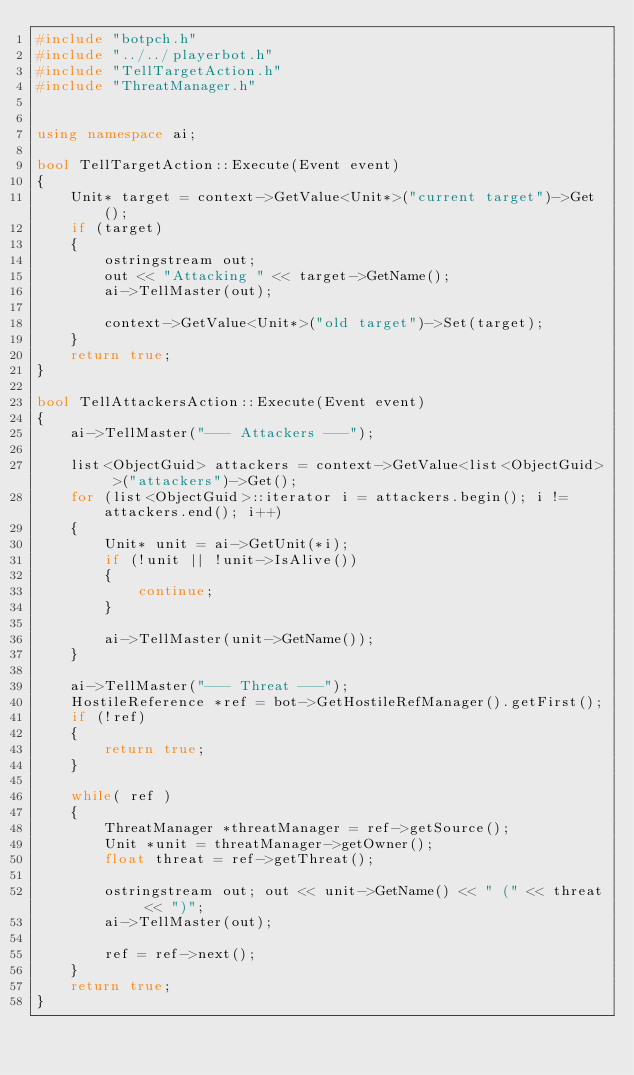Convert code to text. <code><loc_0><loc_0><loc_500><loc_500><_C++_>#include "botpch.h"
#include "../../playerbot.h"
#include "TellTargetAction.h"
#include "ThreatManager.h"


using namespace ai;

bool TellTargetAction::Execute(Event event)
{
    Unit* target = context->GetValue<Unit*>("current target")->Get();
    if (target)
    {
        ostringstream out;
        out << "Attacking " << target->GetName();
        ai->TellMaster(out);

        context->GetValue<Unit*>("old target")->Set(target);
    }
    return true;
}

bool TellAttackersAction::Execute(Event event)
{
    ai->TellMaster("--- Attackers ---");

    list<ObjectGuid> attackers = context->GetValue<list<ObjectGuid> >("attackers")->Get();
    for (list<ObjectGuid>::iterator i = attackers.begin(); i != attackers.end(); i++)
    {
        Unit* unit = ai->GetUnit(*i);
        if (!unit || !unit->IsAlive())
        {
            continue;
        }

        ai->TellMaster(unit->GetName());
    }

    ai->TellMaster("--- Threat ---");
    HostileReference *ref = bot->GetHostileRefManager().getFirst();
    if (!ref)
    {
        return true;
    }

    while( ref )
    {
        ThreatManager *threatManager = ref->getSource();
        Unit *unit = threatManager->getOwner();
        float threat = ref->getThreat();

        ostringstream out; out << unit->GetName() << " (" << threat << ")";
        ai->TellMaster(out);

        ref = ref->next();
    }
    return true;
}
</code> 